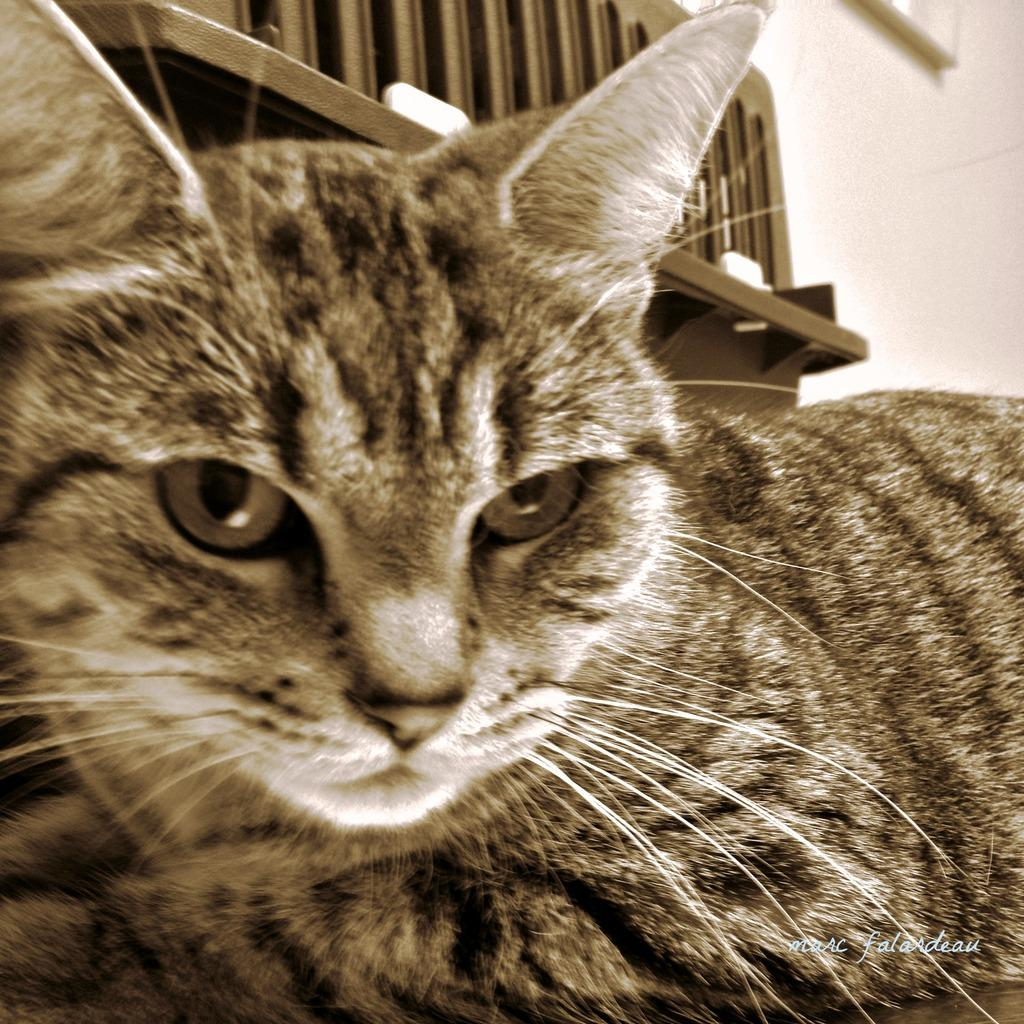What is the main subject in the foreground of the image? There is a cat in the foreground of the image. What can be seen in the background of the image? There is a bench and a wall in the background of the image. What is the title of the book the cat is reading in the image? There is no book present in the image, and therefore no title can be determined. 